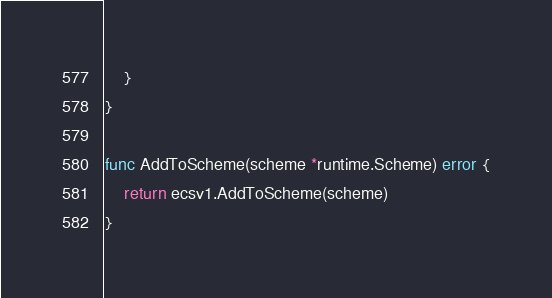<code> <loc_0><loc_0><loc_500><loc_500><_Go_>	}
}

func AddToScheme(scheme *runtime.Scheme) error {
	return ecsv1.AddToScheme(scheme)
}
</code> 